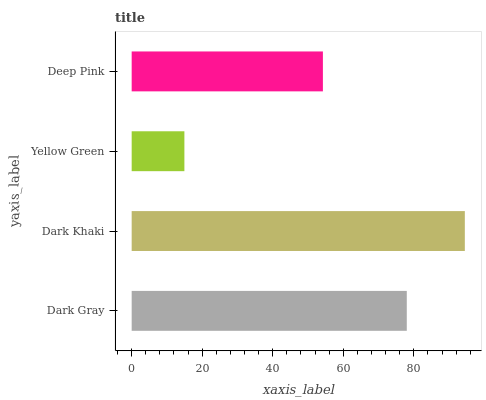Is Yellow Green the minimum?
Answer yes or no. Yes. Is Dark Khaki the maximum?
Answer yes or no. Yes. Is Dark Khaki the minimum?
Answer yes or no. No. Is Yellow Green the maximum?
Answer yes or no. No. Is Dark Khaki greater than Yellow Green?
Answer yes or no. Yes. Is Yellow Green less than Dark Khaki?
Answer yes or no. Yes. Is Yellow Green greater than Dark Khaki?
Answer yes or no. No. Is Dark Khaki less than Yellow Green?
Answer yes or no. No. Is Dark Gray the high median?
Answer yes or no. Yes. Is Deep Pink the low median?
Answer yes or no. Yes. Is Yellow Green the high median?
Answer yes or no. No. Is Yellow Green the low median?
Answer yes or no. No. 